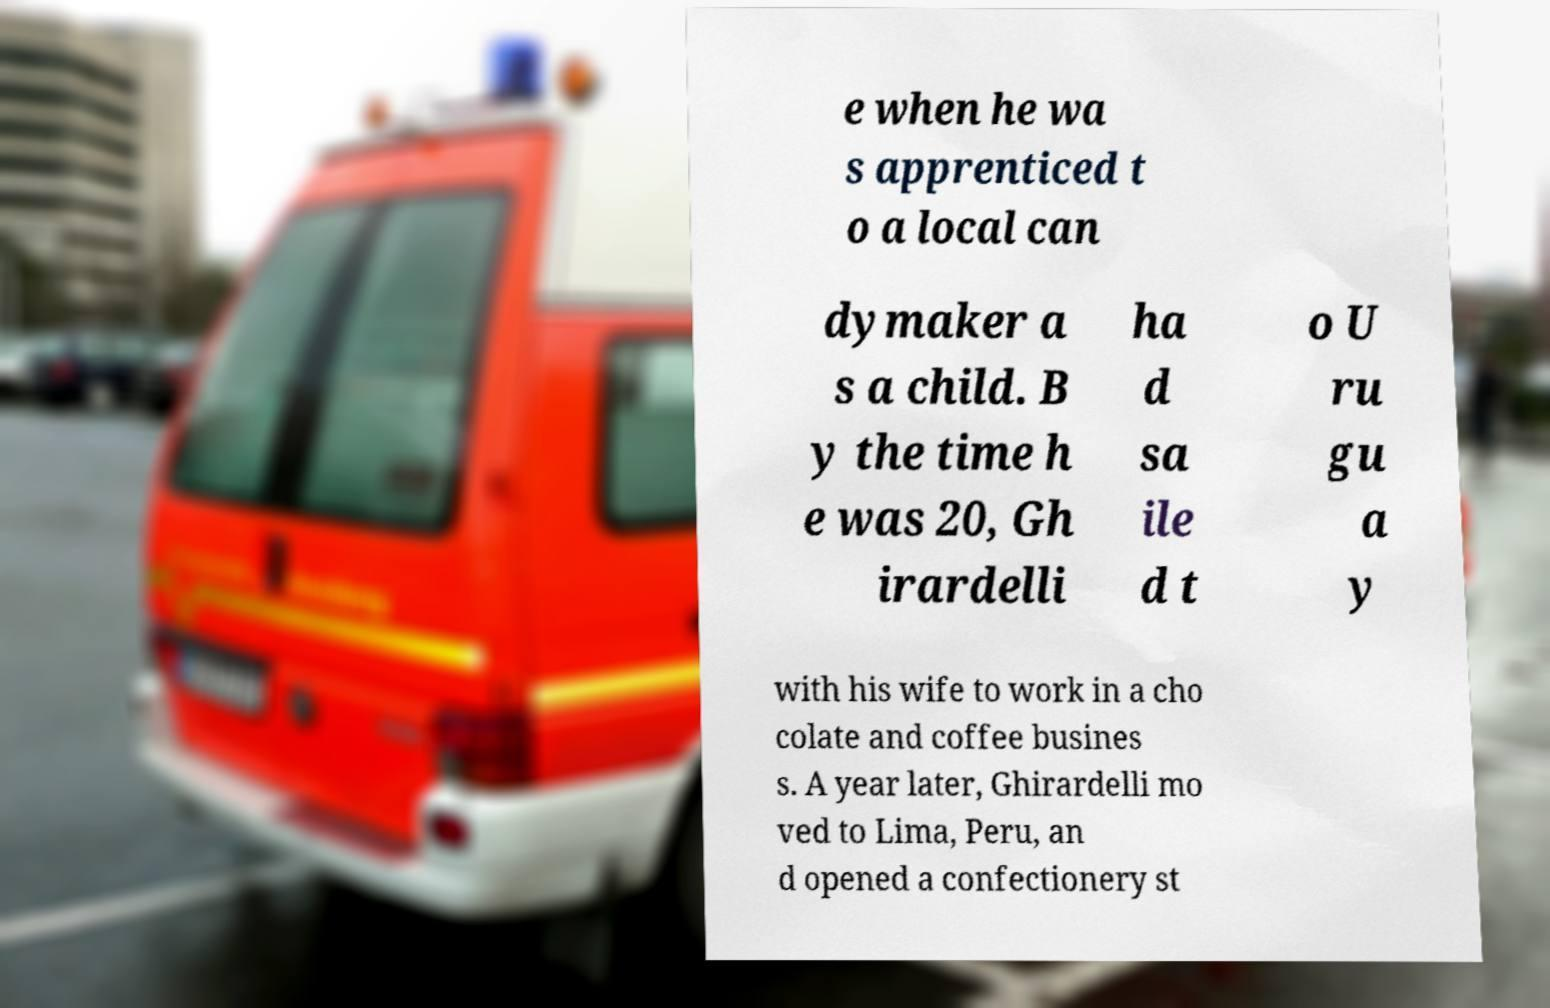There's text embedded in this image that I need extracted. Can you transcribe it verbatim? e when he wa s apprenticed t o a local can dymaker a s a child. B y the time h e was 20, Gh irardelli ha d sa ile d t o U ru gu a y with his wife to work in a cho colate and coffee busines s. A year later, Ghirardelli mo ved to Lima, Peru, an d opened a confectionery st 